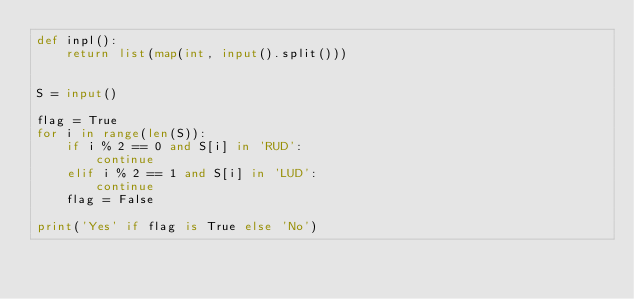<code> <loc_0><loc_0><loc_500><loc_500><_Python_>def inpl():
    return list(map(int, input().split()))


S = input()

flag = True
for i in range(len(S)):
    if i % 2 == 0 and S[i] in 'RUD':
        continue
    elif i % 2 == 1 and S[i] in 'LUD':
        continue
    flag = False

print('Yes' if flag is True else 'No')
</code> 